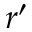Convert formula to latex. <formula><loc_0><loc_0><loc_500><loc_500>r ^ { \prime }</formula> 